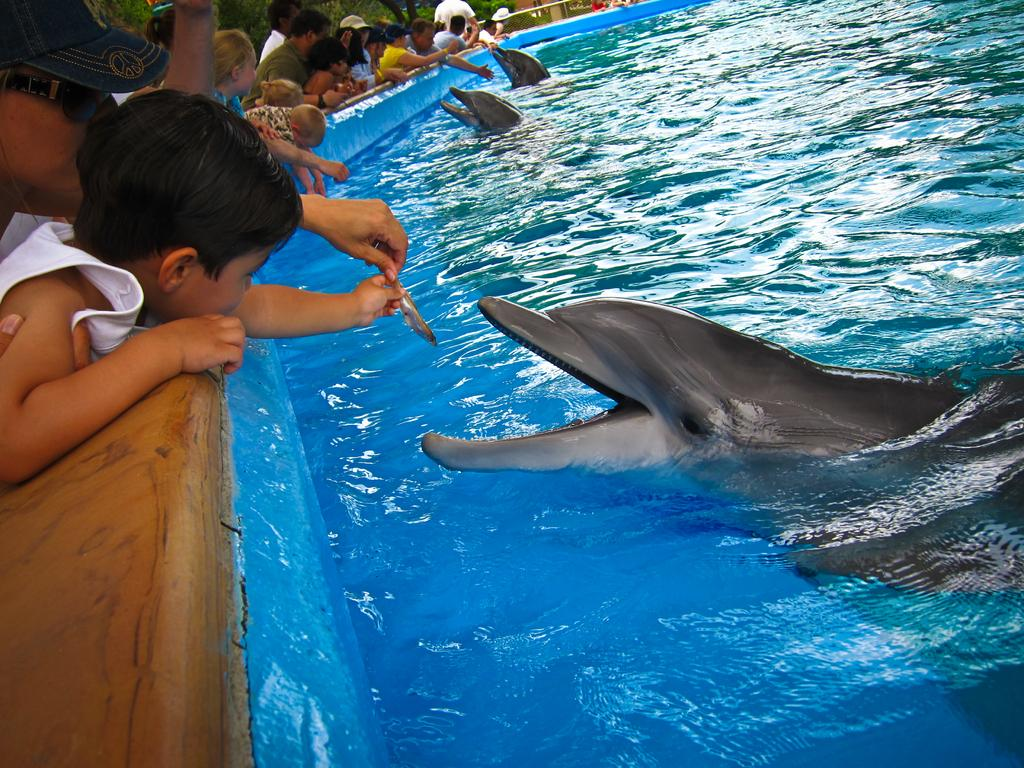Who is present in the image? There are people in the image. What are the people doing in the image? The people are feeding dolphins. Where are the dolphins located in the image? The dolphins are in the water. What are the people using to feed the dolphins? Small fishes are being used for feeding the dolphins. What type of protest is happening in the image? There is no protest present in the image; it features people feeding dolphins in the water. Can you tell me what color the pencil is that the dolphin is holding in the image? There is no pencil present in the image, and dolphins do not hold objects like pencils. 